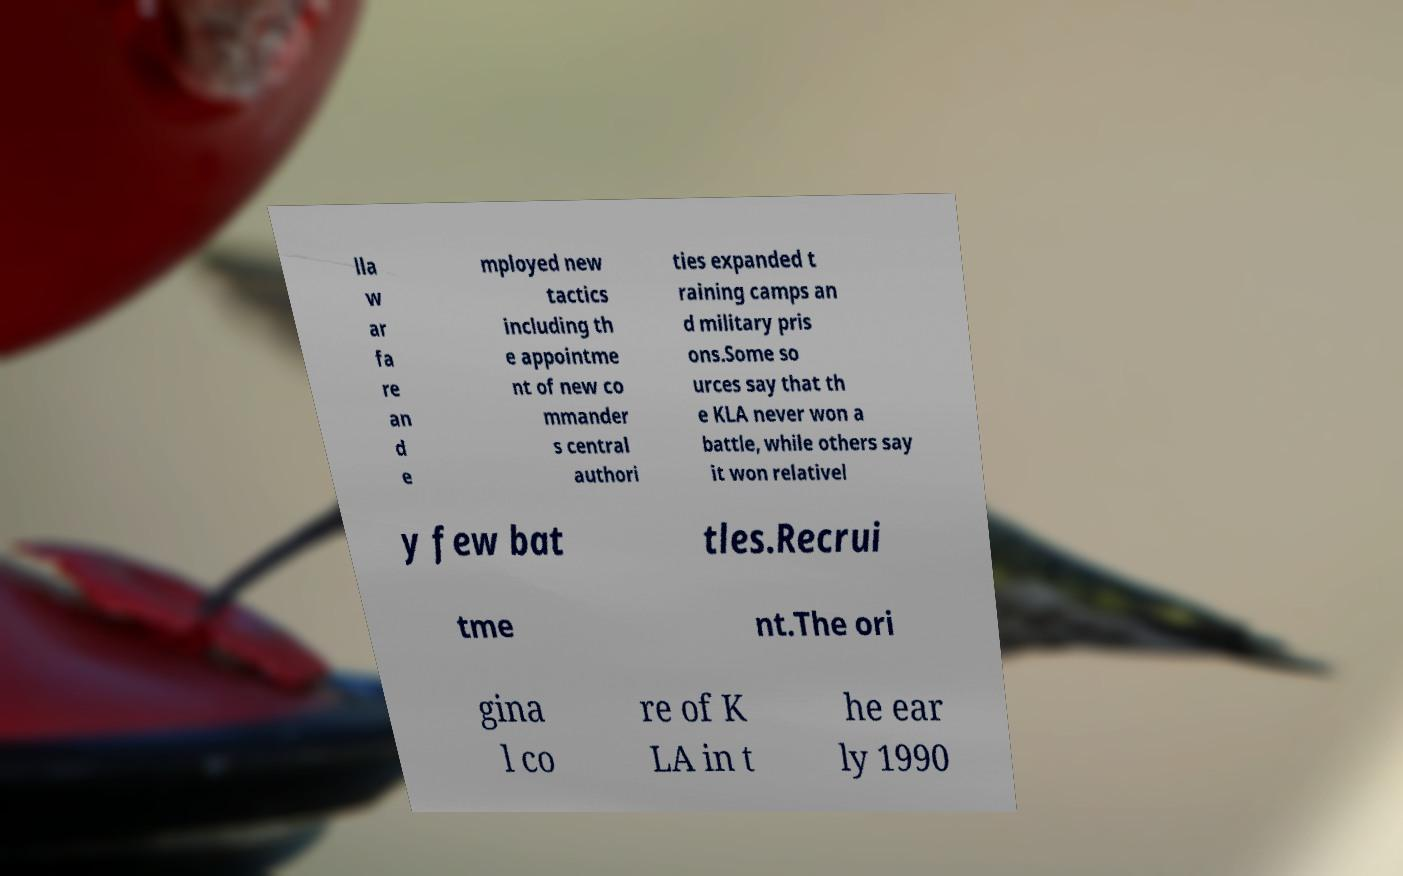Can you read and provide the text displayed in the image?This photo seems to have some interesting text. Can you extract and type it out for me? lla w ar fa re an d e mployed new tactics including th e appointme nt of new co mmander s central authori ties expanded t raining camps an d military pris ons.Some so urces say that th e KLA never won a battle, while others say it won relativel y few bat tles.Recrui tme nt.The ori gina l co re of K LA in t he ear ly 1990 